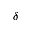Convert formula to latex. <formula><loc_0><loc_0><loc_500><loc_500>\delta</formula> 